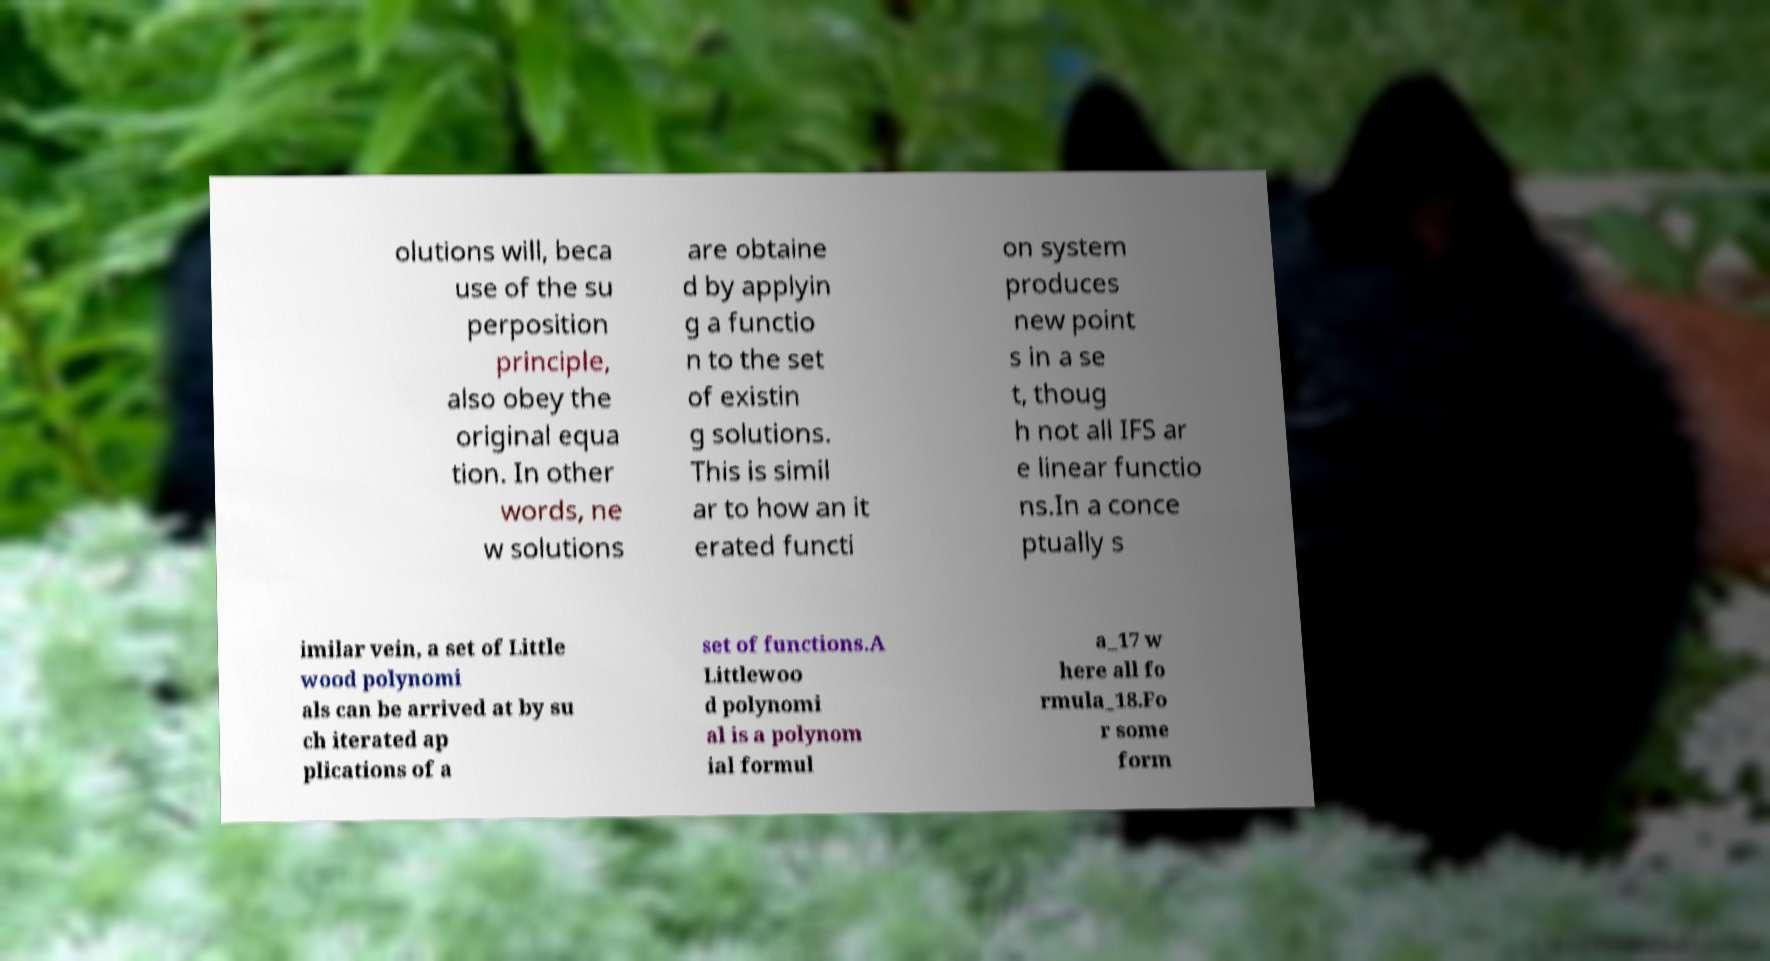Could you assist in decoding the text presented in this image and type it out clearly? olutions will, beca use of the su perposition principle, also obey the original equa tion. In other words, ne w solutions are obtaine d by applyin g a functio n to the set of existin g solutions. This is simil ar to how an it erated functi on system produces new point s in a se t, thoug h not all IFS ar e linear functio ns.In a conce ptually s imilar vein, a set of Little wood polynomi als can be arrived at by su ch iterated ap plications of a set of functions.A Littlewoo d polynomi al is a polynom ial formul a_17 w here all fo rmula_18.Fo r some form 